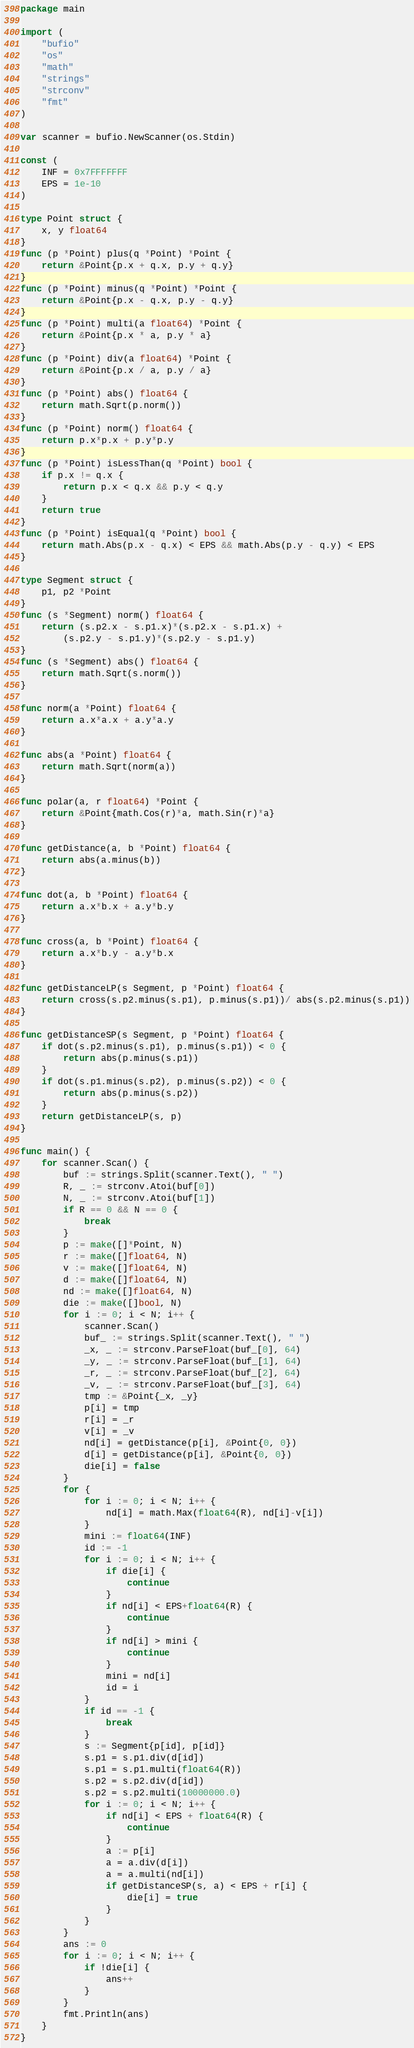Convert code to text. <code><loc_0><loc_0><loc_500><loc_500><_Go_>package main

import (
	"bufio"
	"os"
	"math"
	"strings"
	"strconv"
	"fmt"
)

var scanner = bufio.NewScanner(os.Stdin)

const (
	INF = 0x7FFFFFFF
	EPS = 1e-10
)

type Point struct {
	x, y float64
}
func (p *Point) plus(q *Point) *Point {
	return &Point{p.x + q.x, p.y + q.y}
}
func (p *Point) minus(q *Point) *Point {
	return &Point{p.x - q.x, p.y - q.y}
}
func (p *Point) multi(a float64) *Point {
	return &Point{p.x * a, p.y * a}
}
func (p *Point) div(a float64) *Point {
	return &Point{p.x / a, p.y / a}
}
func (p *Point) abs() float64 {
	return math.Sqrt(p.norm())
}
func (p *Point) norm() float64 {
	return p.x*p.x + p.y*p.y
}
func (p *Point) isLessThan(q *Point) bool {
	if p.x != q.x {
		return p.x < q.x && p.y < q.y
	}
	return true
}
func (p *Point) isEqual(q *Point) bool {
	return math.Abs(p.x - q.x) < EPS && math.Abs(p.y - q.y) < EPS
}

type Segment struct {
	p1, p2 *Point
}
func (s *Segment) norm() float64 {
	return (s.p2.x - s.p1.x)*(s.p2.x - s.p1.x) +
		(s.p2.y - s.p1.y)*(s.p2.y - s.p1.y)
}
func (s *Segment) abs() float64 {
	return math.Sqrt(s.norm())
}

func norm(a *Point) float64 {
	return a.x*a.x + a.y*a.y
}

func abs(a *Point) float64 {
	return math.Sqrt(norm(a))
}

func polar(a, r float64) *Point {
	return &Point{math.Cos(r)*a, math.Sin(r)*a}
}

func getDistance(a, b *Point) float64 {
	return abs(a.minus(b))
}

func dot(a, b *Point) float64 {
	return a.x*b.x + a.y*b.y
}

func cross(a, b *Point) float64 {
	return a.x*b.y - a.y*b.x
}

func getDistanceLP(s Segment, p *Point) float64 {
	return cross(s.p2.minus(s.p1), p.minus(s.p1))/ abs(s.p2.minus(s.p1))
}

func getDistanceSP(s Segment, p *Point) float64 {
	if dot(s.p2.minus(s.p1), p.minus(s.p1)) < 0 {
		return abs(p.minus(s.p1))
	}
	if dot(s.p1.minus(s.p2), p.minus(s.p2)) < 0 {
		return abs(p.minus(s.p2))
	}
	return getDistanceLP(s, p)
}

func main() {
	for scanner.Scan() {
		buf := strings.Split(scanner.Text(), " ")
		R, _ := strconv.Atoi(buf[0])
		N, _ := strconv.Atoi(buf[1])
		if R == 0 && N == 0 {
			break
		}
		p := make([]*Point, N)
		r := make([]float64, N)
		v := make([]float64, N)
		d := make([]float64, N)
		nd := make([]float64, N)
		die := make([]bool, N)
		for i := 0; i < N; i++ {
			scanner.Scan()
			buf_ := strings.Split(scanner.Text(), " ")
			_x, _ := strconv.ParseFloat(buf_[0], 64)
			_y, _ := strconv.ParseFloat(buf_[1], 64)
			_r, _ := strconv.ParseFloat(buf_[2], 64)
			_v, _ := strconv.ParseFloat(buf_[3], 64)
			tmp := &Point{_x, _y}
			p[i] = tmp
			r[i] = _r
			v[i] = _v
			nd[i] = getDistance(p[i], &Point{0, 0})
			d[i] = getDistance(p[i], &Point{0, 0})
			die[i] = false
		}
		for {
			for i := 0; i < N; i++ {
				nd[i] = math.Max(float64(R), nd[i]-v[i])
			}
			mini := float64(INF)
			id := -1
			for i := 0; i < N; i++ {
				if die[i] {
					continue
				}
				if nd[i] < EPS+float64(R) {
					continue
				}
				if nd[i] > mini {
					continue
				}
				mini = nd[i]
				id = i
			}
			if id == -1 {
				break
			}
			s := Segment{p[id], p[id]}
			s.p1 = s.p1.div(d[id])
			s.p1 = s.p1.multi(float64(R))
			s.p2 = s.p2.div(d[id])
			s.p2 = s.p2.multi(10000000.0)
			for i := 0; i < N; i++ {
				if nd[i] < EPS + float64(R) {
					continue
				}
				a := p[i]
				a = a.div(d[i])
				a = a.multi(nd[i])
				if getDistanceSP(s, a) < EPS + r[i] {
					die[i] = true
				}
			}
		}
		ans := 0
		for i := 0; i < N; i++ {
			if !die[i] {
				ans++
			}
		}
		fmt.Println(ans)
	}
}
</code> 